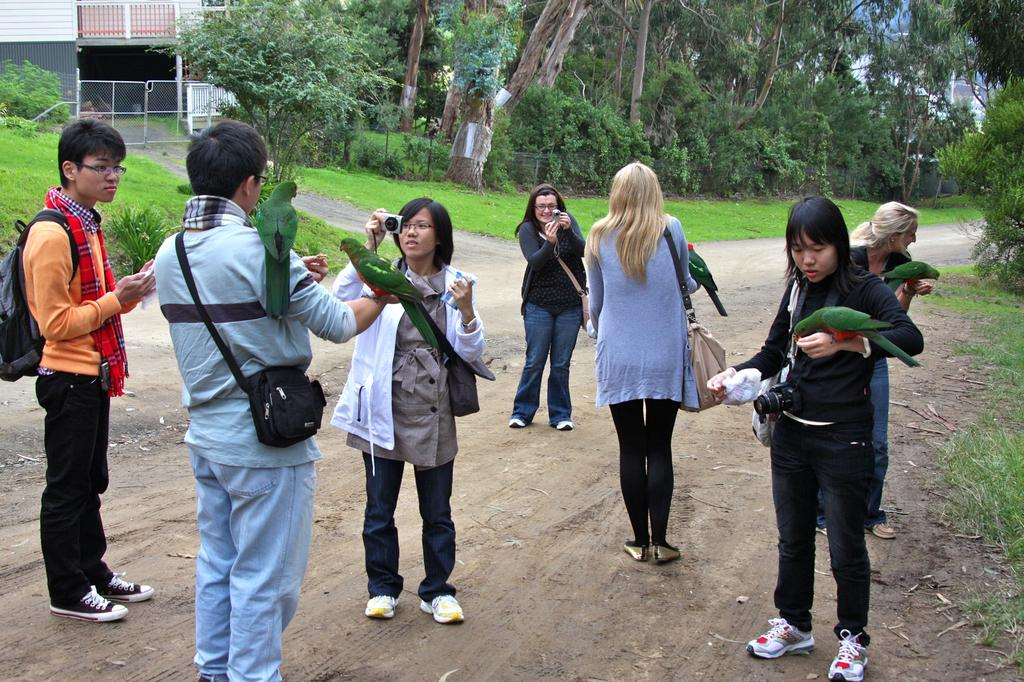How many people are in the image? There are people in the image, but the exact number is not specified. What are two of the people doing in the image? Two of the people are taking pictures. What animals can be seen on some of the people in the image? There are parrots on some of the people in the image. What type of vegetation is present in the image? There are trees and plants in the image. What type of structure is visible in the image? There is a house in the image. What part of the natural environment is visible in the image? The sky is visible in the image. What type of umbrella is being used to perform the operation in the image? There is no umbrella or operation present in the image. 